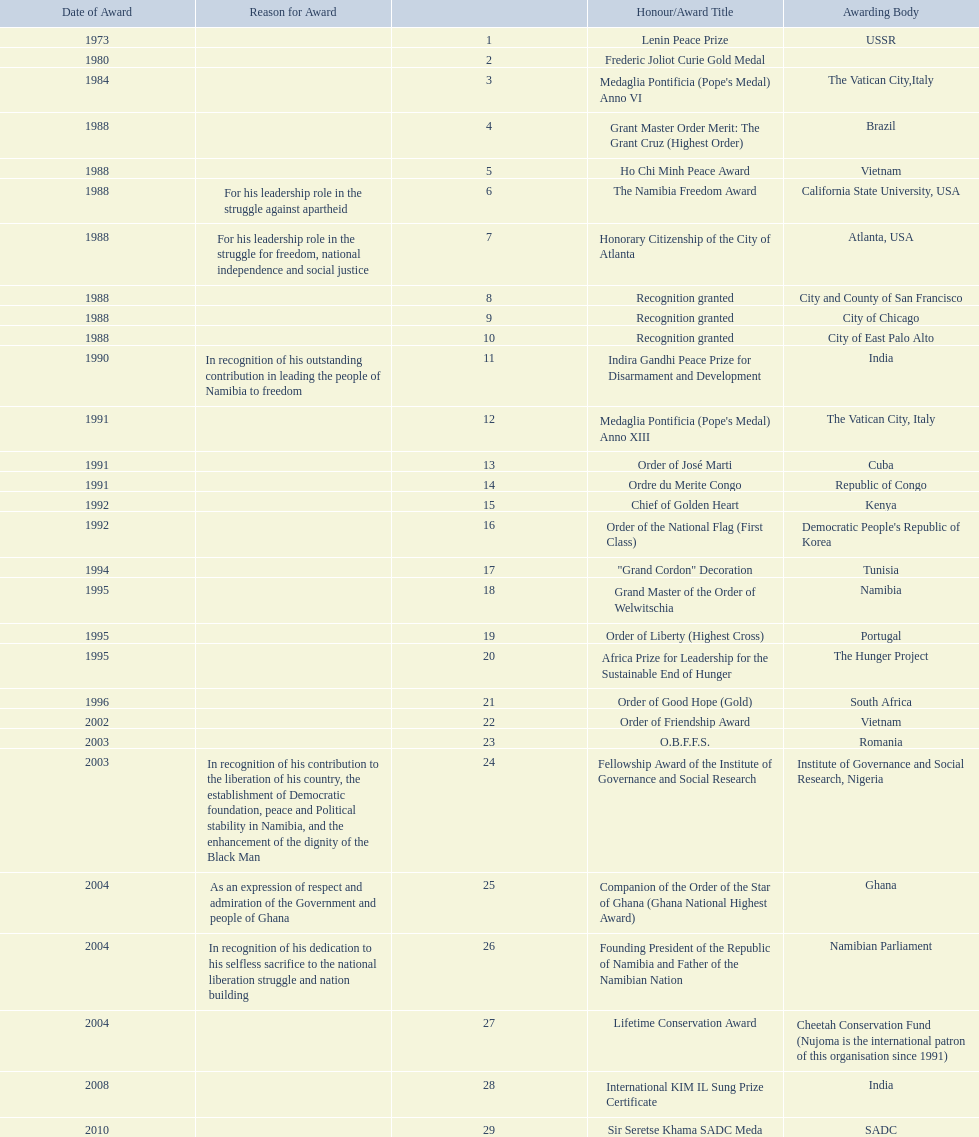What awards has sam nujoma been awarded? Lenin Peace Prize, Frederic Joliot Curie Gold Medal, Medaglia Pontificia (Pope's Medal) Anno VI, Grant Master Order Merit: The Grant Cruz (Highest Order), Ho Chi Minh Peace Award, The Namibia Freedom Award, Honorary Citizenship of the City of Atlanta, Recognition granted, Recognition granted, Recognition granted, Indira Gandhi Peace Prize for Disarmament and Development, Medaglia Pontificia (Pope's Medal) Anno XIII, Order of José Marti, Ordre du Merite Congo, Chief of Golden Heart, Order of the National Flag (First Class), "Grand Cordon" Decoration, Grand Master of the Order of Welwitschia, Order of Liberty (Highest Cross), Africa Prize for Leadership for the Sustainable End of Hunger, Order of Good Hope (Gold), Order of Friendship Award, O.B.F.F.S., Fellowship Award of the Institute of Governance and Social Research, Companion of the Order of the Star of Ghana (Ghana National Highest Award), Founding President of the Republic of Namibia and Father of the Namibian Nation, Lifetime Conservation Award, International KIM IL Sung Prize Certificate, Sir Seretse Khama SADC Meda. By which awarding body did sam nujoma receive the o.b.f.f.s award? Romania. 